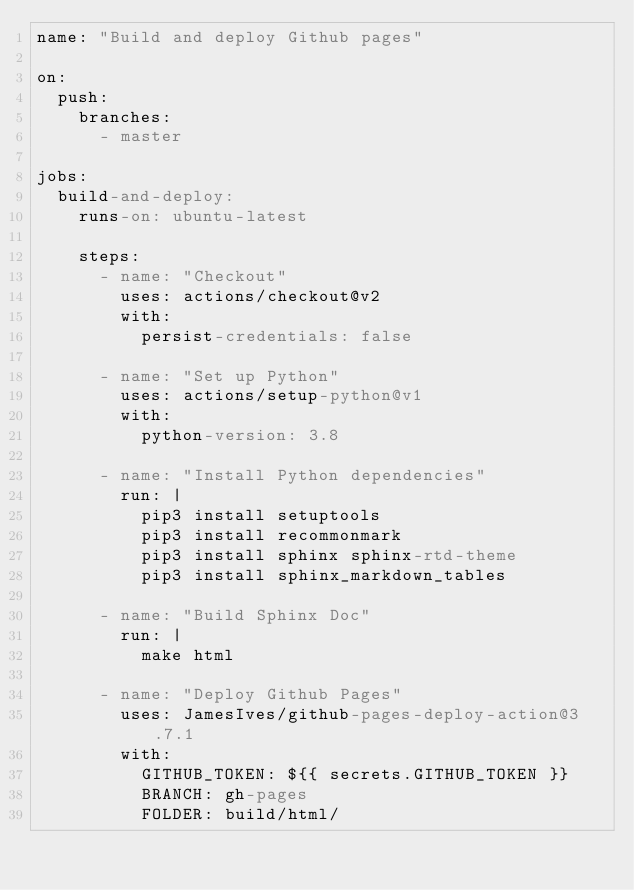<code> <loc_0><loc_0><loc_500><loc_500><_YAML_>name: "Build and deploy Github pages"

on:
  push:
    branches:
      - master

jobs:
  build-and-deploy:
    runs-on: ubuntu-latest

    steps:
      - name: "Checkout"
        uses: actions/checkout@v2
        with:
          persist-credentials: false

      - name: "Set up Python"
        uses: actions/setup-python@v1
        with:
          python-version: 3.8

      - name: "Install Python dependencies"
        run: |
          pip3 install setuptools
          pip3 install recommonmark
          pip3 install sphinx sphinx-rtd-theme
          pip3 install sphinx_markdown_tables

      - name: "Build Sphinx Doc"
        run: |
          make html

      - name: "Deploy Github Pages"
        uses: JamesIves/github-pages-deploy-action@3.7.1
        with:
          GITHUB_TOKEN: ${{ secrets.GITHUB_TOKEN }}
          BRANCH: gh-pages
          FOLDER: build/html/</code> 